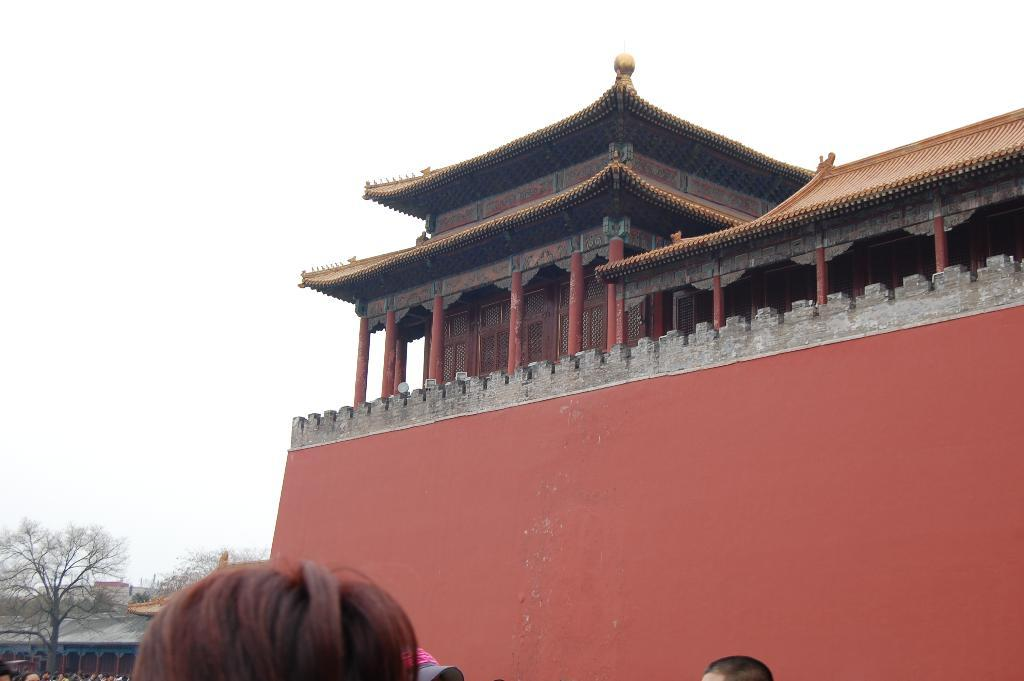What can be seen in the image that belongs to a person? There are persons' heads visible in the image. What type of structure is present in the image? There is a building in the image. What can be seen in the background of the image? There are trees, buildings, and the sky visible in the background of the image. Can you tell me the name of the soap used by the person in the image? There is no soap present in the image, and therefore no information about the soap can be provided. 